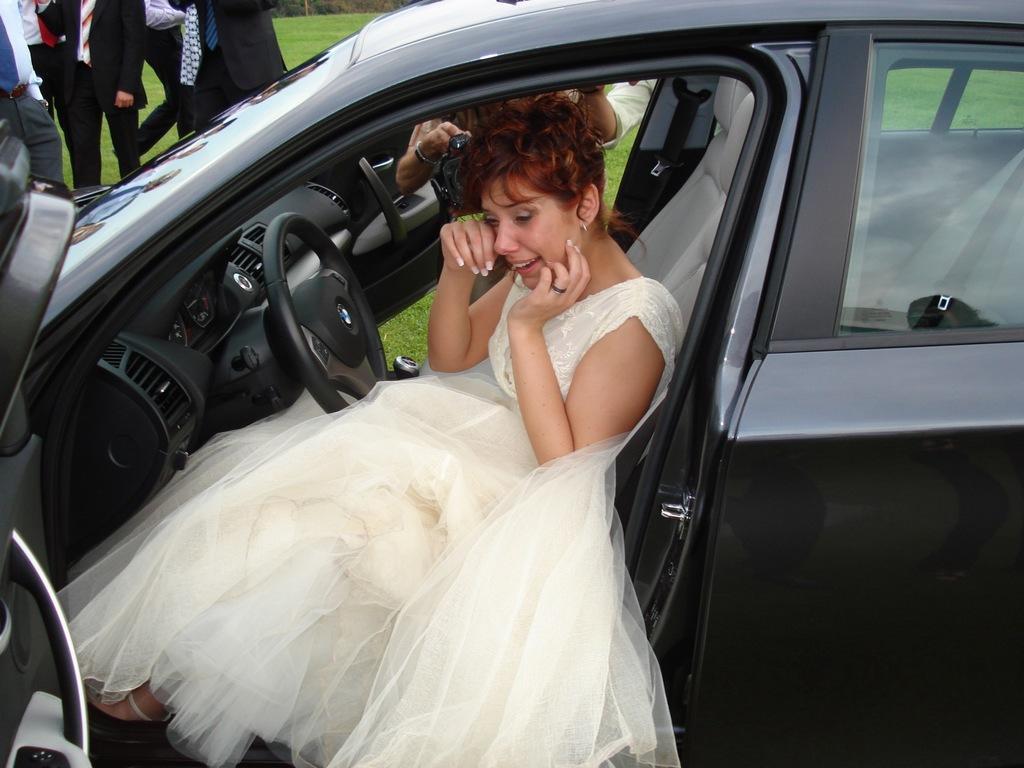How would you summarize this image in a sentence or two? A woman is crying sitting in a car wearing gown. In the background many persons are standing. Also other side a lady is holding a camera. Also there is a grass lawn. 